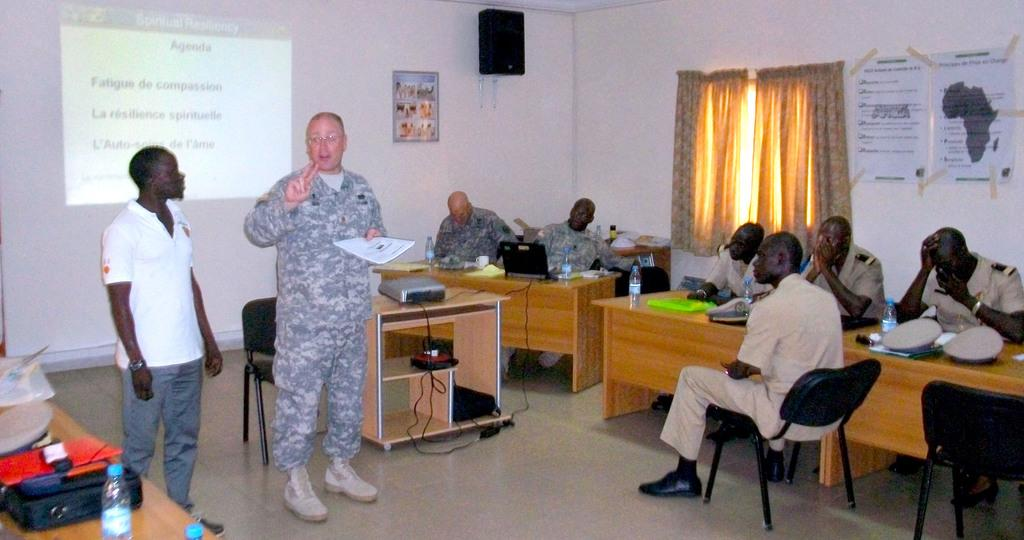<image>
Render a clear and concise summary of the photo. A man in an army uniform stands in front of a screen that says agenda at the top. 